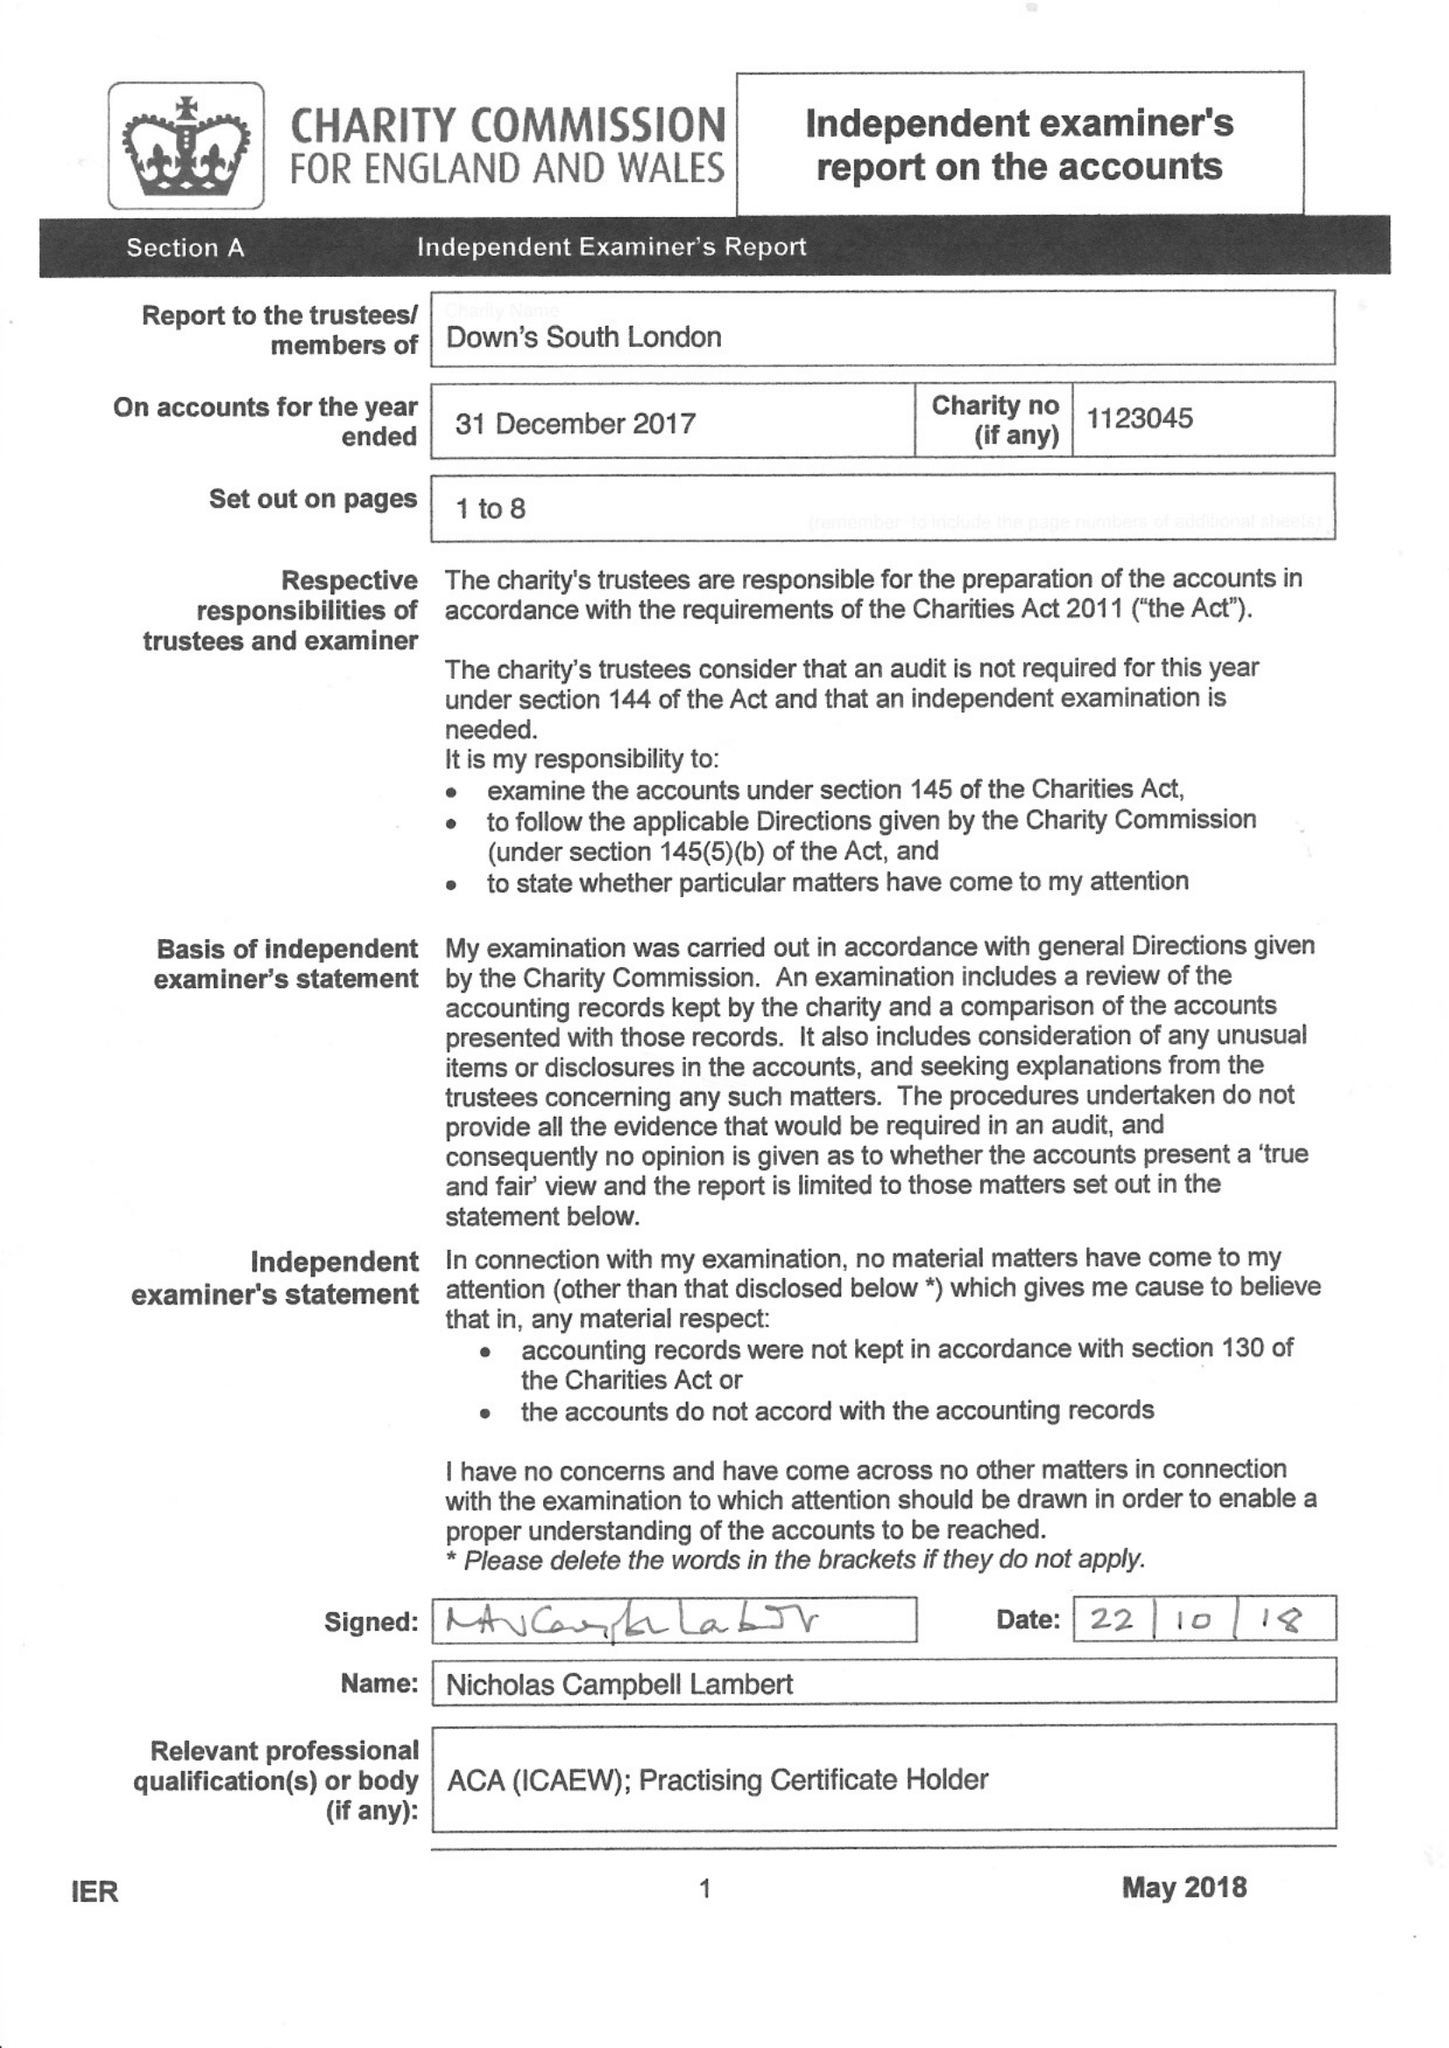What is the value for the charity_number?
Answer the question using a single word or phrase. 1123045 